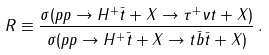Convert formula to latex. <formula><loc_0><loc_0><loc_500><loc_500>R \equiv \frac { \sigma ( p p \to H ^ { + } \bar { t } + X \to \tau ^ { + } \nu t + X ) } { \sigma ( p p \to H ^ { + } \bar { t } + X \to t \bar { b } \bar { t } + X ) } \, .</formula> 